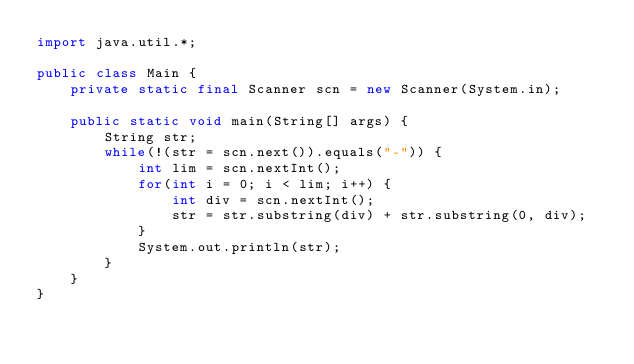<code> <loc_0><loc_0><loc_500><loc_500><_Java_>import java.util.*;

public class Main {
    private static final Scanner scn = new Scanner(System.in);
    
    public static void main(String[] args) {
        String str;
        while(!(str = scn.next()).equals("-")) {
            int lim = scn.nextInt();
            for(int i = 0; i < lim; i++) {
                int div = scn.nextInt();
                str = str.substring(div) + str.substring(0, div);
            }
            System.out.println(str);
        }
    }
}</code> 